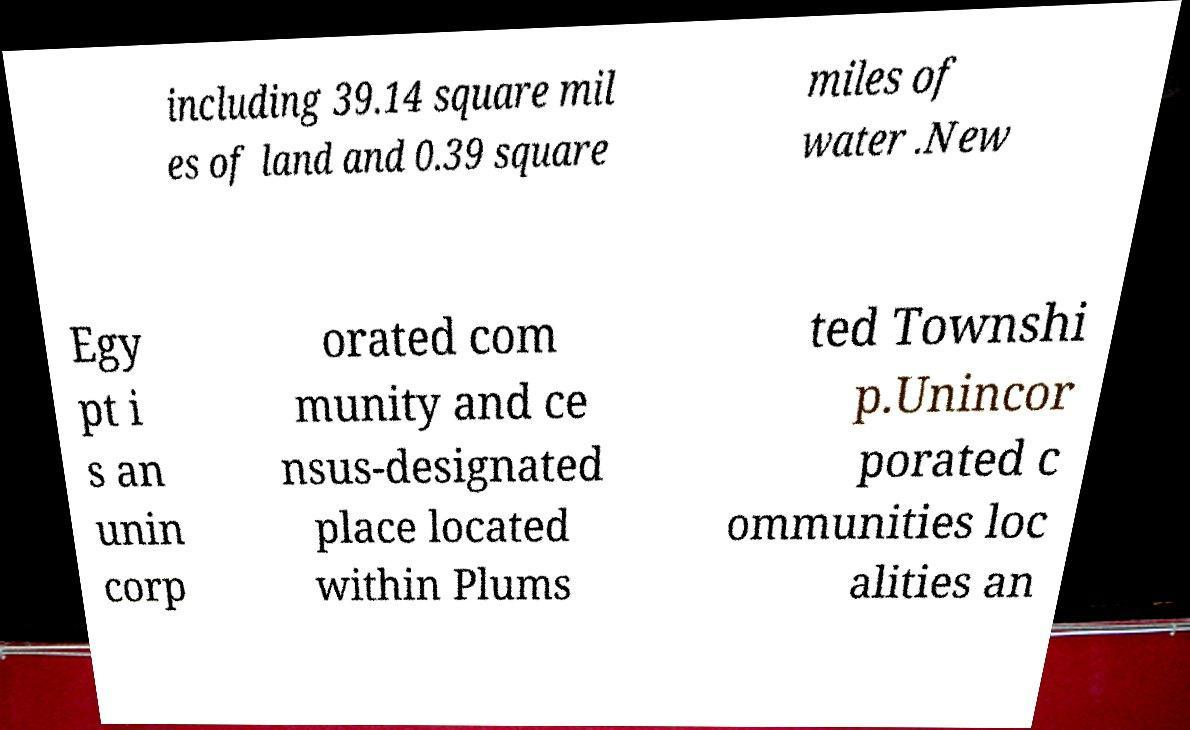Could you extract and type out the text from this image? including 39.14 square mil es of land and 0.39 square miles of water .New Egy pt i s an unin corp orated com munity and ce nsus-designated place located within Plums ted Townshi p.Unincor porated c ommunities loc alities an 